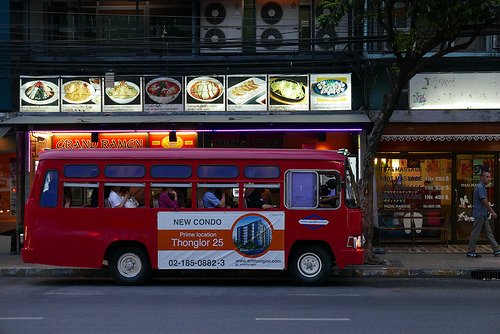<image>
Can you confirm if the bus is next to the man? No. The bus is not positioned next to the man. They are located in different areas of the scene. 